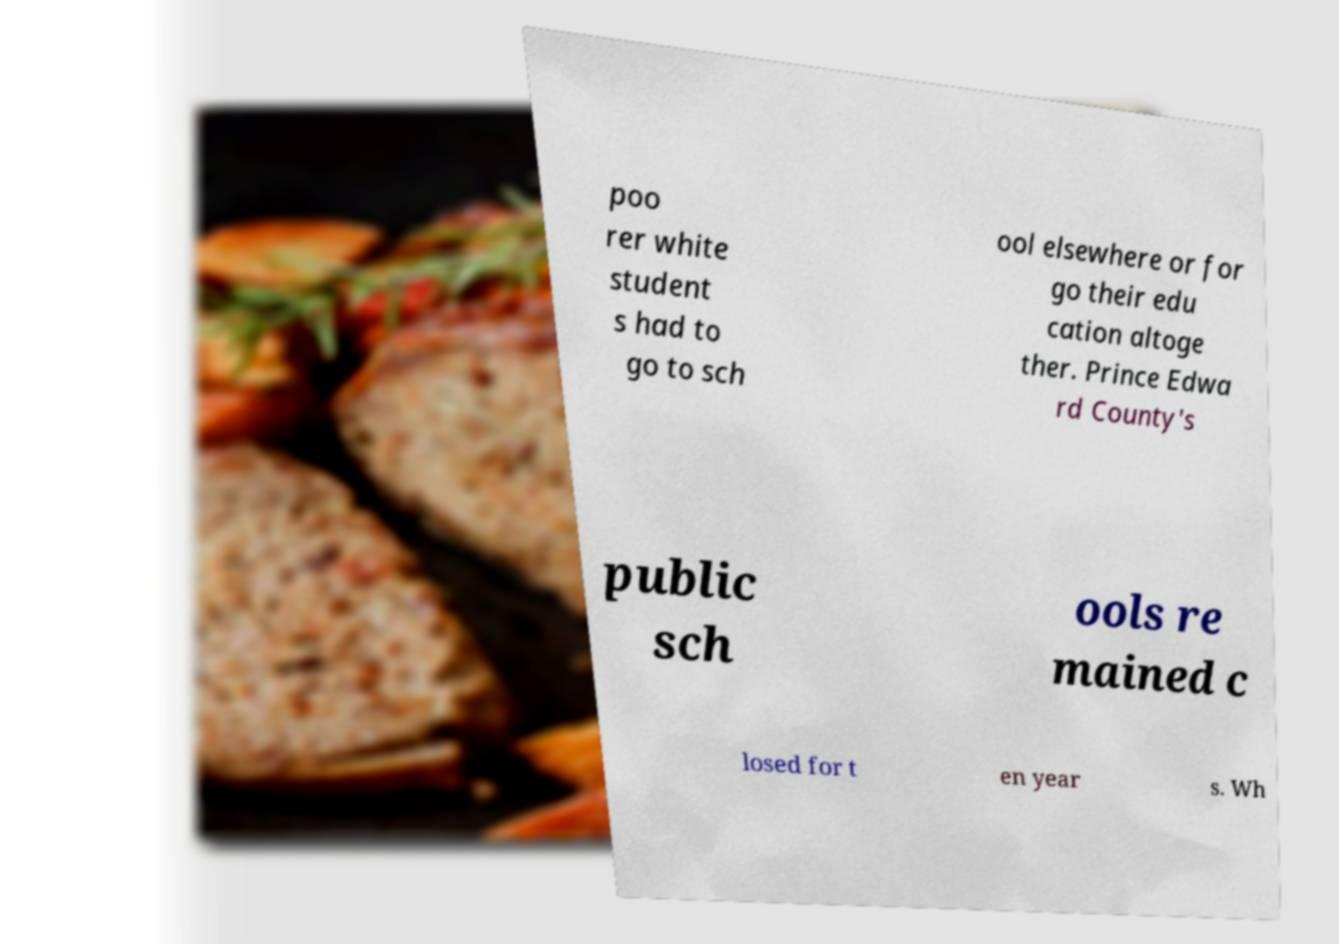For documentation purposes, I need the text within this image transcribed. Could you provide that? poo rer white student s had to go to sch ool elsewhere or for go their edu cation altoge ther. Prince Edwa rd County's public sch ools re mained c losed for t en year s. Wh 